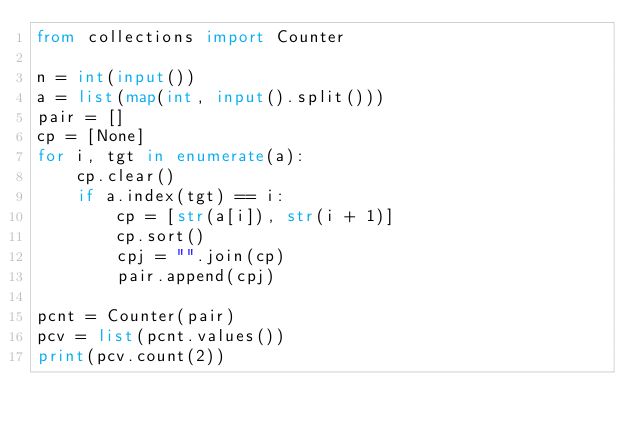Convert code to text. <code><loc_0><loc_0><loc_500><loc_500><_Python_>from collections import Counter

n = int(input())
a = list(map(int, input().split()))
pair = []
cp = [None]
for i, tgt in enumerate(a):
    cp.clear()
    if a.index(tgt) == i:
        cp = [str(a[i]), str(i + 1)]
        cp.sort()
        cpj = "".join(cp)
        pair.append(cpj)

pcnt = Counter(pair)
pcv = list(pcnt.values())
print(pcv.count(2))
</code> 